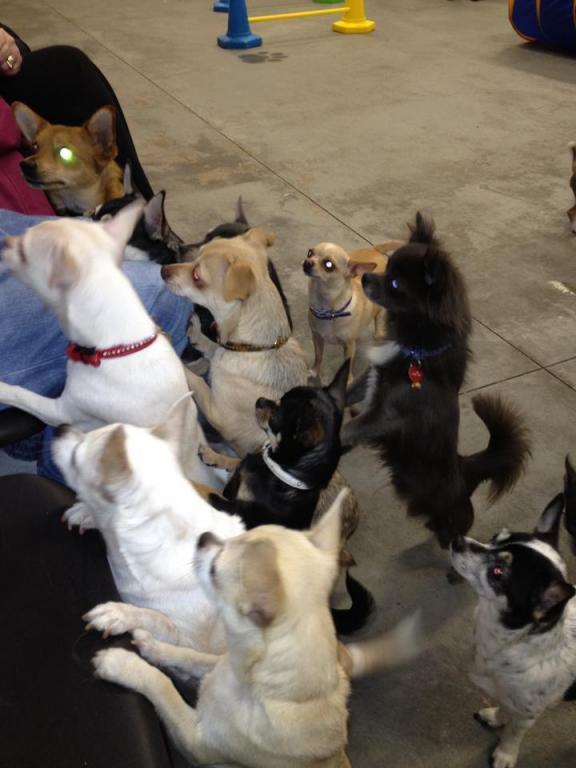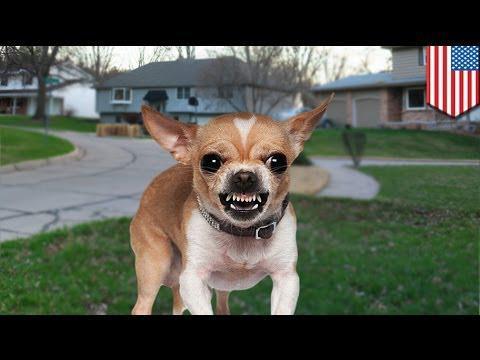The first image is the image on the left, the second image is the image on the right. For the images displayed, is the sentence "There is exactly one real dog in the image on the left." factually correct? Answer yes or no. No. 